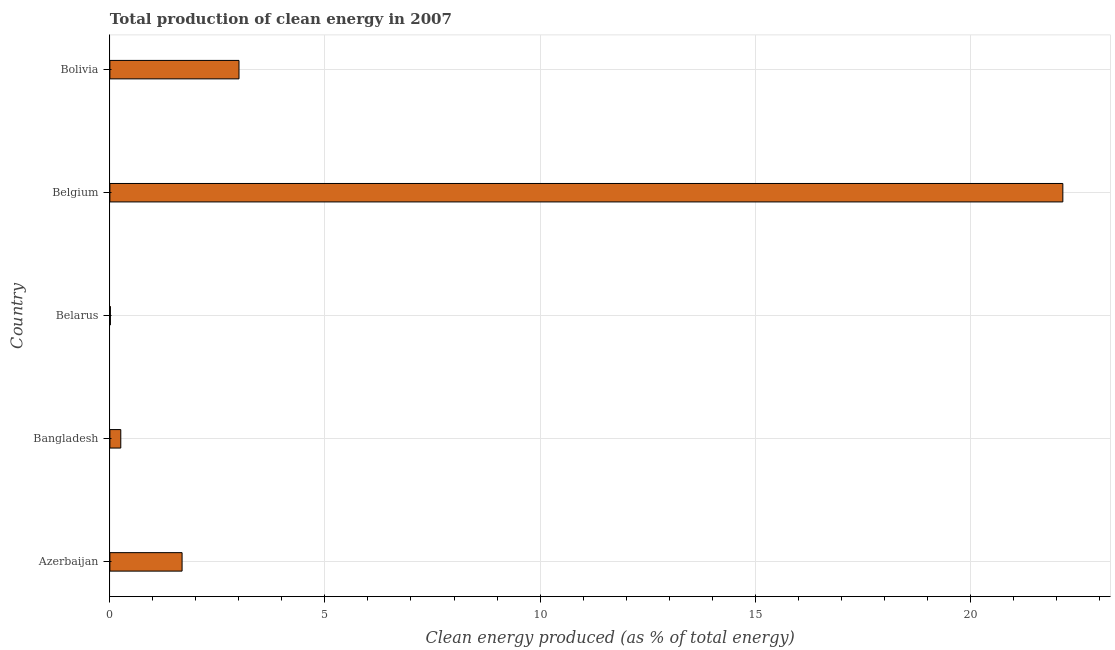Does the graph contain any zero values?
Offer a very short reply. No. What is the title of the graph?
Ensure brevity in your answer.  Total production of clean energy in 2007. What is the label or title of the X-axis?
Offer a very short reply. Clean energy produced (as % of total energy). What is the production of clean energy in Belarus?
Make the answer very short. 0.01. Across all countries, what is the maximum production of clean energy?
Your response must be concise. 22.15. Across all countries, what is the minimum production of clean energy?
Offer a terse response. 0.01. In which country was the production of clean energy maximum?
Your response must be concise. Belgium. In which country was the production of clean energy minimum?
Give a very brief answer. Belarus. What is the sum of the production of clean energy?
Your response must be concise. 27.1. What is the difference between the production of clean energy in Belgium and Bolivia?
Offer a very short reply. 19.15. What is the average production of clean energy per country?
Your answer should be compact. 5.42. What is the median production of clean energy?
Your answer should be compact. 1.68. In how many countries, is the production of clean energy greater than 2 %?
Make the answer very short. 2. What is the ratio of the production of clean energy in Bangladesh to that in Belgium?
Provide a succinct answer. 0.01. Is the difference between the production of clean energy in Belarus and Belgium greater than the difference between any two countries?
Make the answer very short. Yes. What is the difference between the highest and the second highest production of clean energy?
Your response must be concise. 19.15. What is the difference between the highest and the lowest production of clean energy?
Give a very brief answer. 22.14. Are all the bars in the graph horizontal?
Make the answer very short. Yes. Are the values on the major ticks of X-axis written in scientific E-notation?
Your answer should be very brief. No. What is the Clean energy produced (as % of total energy) of Azerbaijan?
Make the answer very short. 1.68. What is the Clean energy produced (as % of total energy) in Bangladesh?
Give a very brief answer. 0.25. What is the Clean energy produced (as % of total energy) of Belarus?
Provide a short and direct response. 0.01. What is the Clean energy produced (as % of total energy) in Belgium?
Your response must be concise. 22.15. What is the Clean energy produced (as % of total energy) of Bolivia?
Give a very brief answer. 3. What is the difference between the Clean energy produced (as % of total energy) in Azerbaijan and Bangladesh?
Keep it short and to the point. 1.43. What is the difference between the Clean energy produced (as % of total energy) in Azerbaijan and Belarus?
Your answer should be very brief. 1.67. What is the difference between the Clean energy produced (as % of total energy) in Azerbaijan and Belgium?
Your answer should be very brief. -20.48. What is the difference between the Clean energy produced (as % of total energy) in Azerbaijan and Bolivia?
Your answer should be compact. -1.32. What is the difference between the Clean energy produced (as % of total energy) in Bangladesh and Belarus?
Your answer should be very brief. 0.24. What is the difference between the Clean energy produced (as % of total energy) in Bangladesh and Belgium?
Your answer should be very brief. -21.9. What is the difference between the Clean energy produced (as % of total energy) in Bangladesh and Bolivia?
Your answer should be compact. -2.75. What is the difference between the Clean energy produced (as % of total energy) in Belarus and Belgium?
Keep it short and to the point. -22.14. What is the difference between the Clean energy produced (as % of total energy) in Belarus and Bolivia?
Provide a succinct answer. -2.99. What is the difference between the Clean energy produced (as % of total energy) in Belgium and Bolivia?
Provide a short and direct response. 19.15. What is the ratio of the Clean energy produced (as % of total energy) in Azerbaijan to that in Bangladesh?
Ensure brevity in your answer.  6.63. What is the ratio of the Clean energy produced (as % of total energy) in Azerbaijan to that in Belarus?
Offer a very short reply. 151.24. What is the ratio of the Clean energy produced (as % of total energy) in Azerbaijan to that in Belgium?
Ensure brevity in your answer.  0.08. What is the ratio of the Clean energy produced (as % of total energy) in Azerbaijan to that in Bolivia?
Offer a very short reply. 0.56. What is the ratio of the Clean energy produced (as % of total energy) in Bangladesh to that in Belarus?
Your answer should be very brief. 22.82. What is the ratio of the Clean energy produced (as % of total energy) in Bangladesh to that in Belgium?
Give a very brief answer. 0.01. What is the ratio of the Clean energy produced (as % of total energy) in Bangladesh to that in Bolivia?
Your answer should be very brief. 0.08. What is the ratio of the Clean energy produced (as % of total energy) in Belarus to that in Bolivia?
Your answer should be compact. 0. What is the ratio of the Clean energy produced (as % of total energy) in Belgium to that in Bolivia?
Your answer should be very brief. 7.38. 